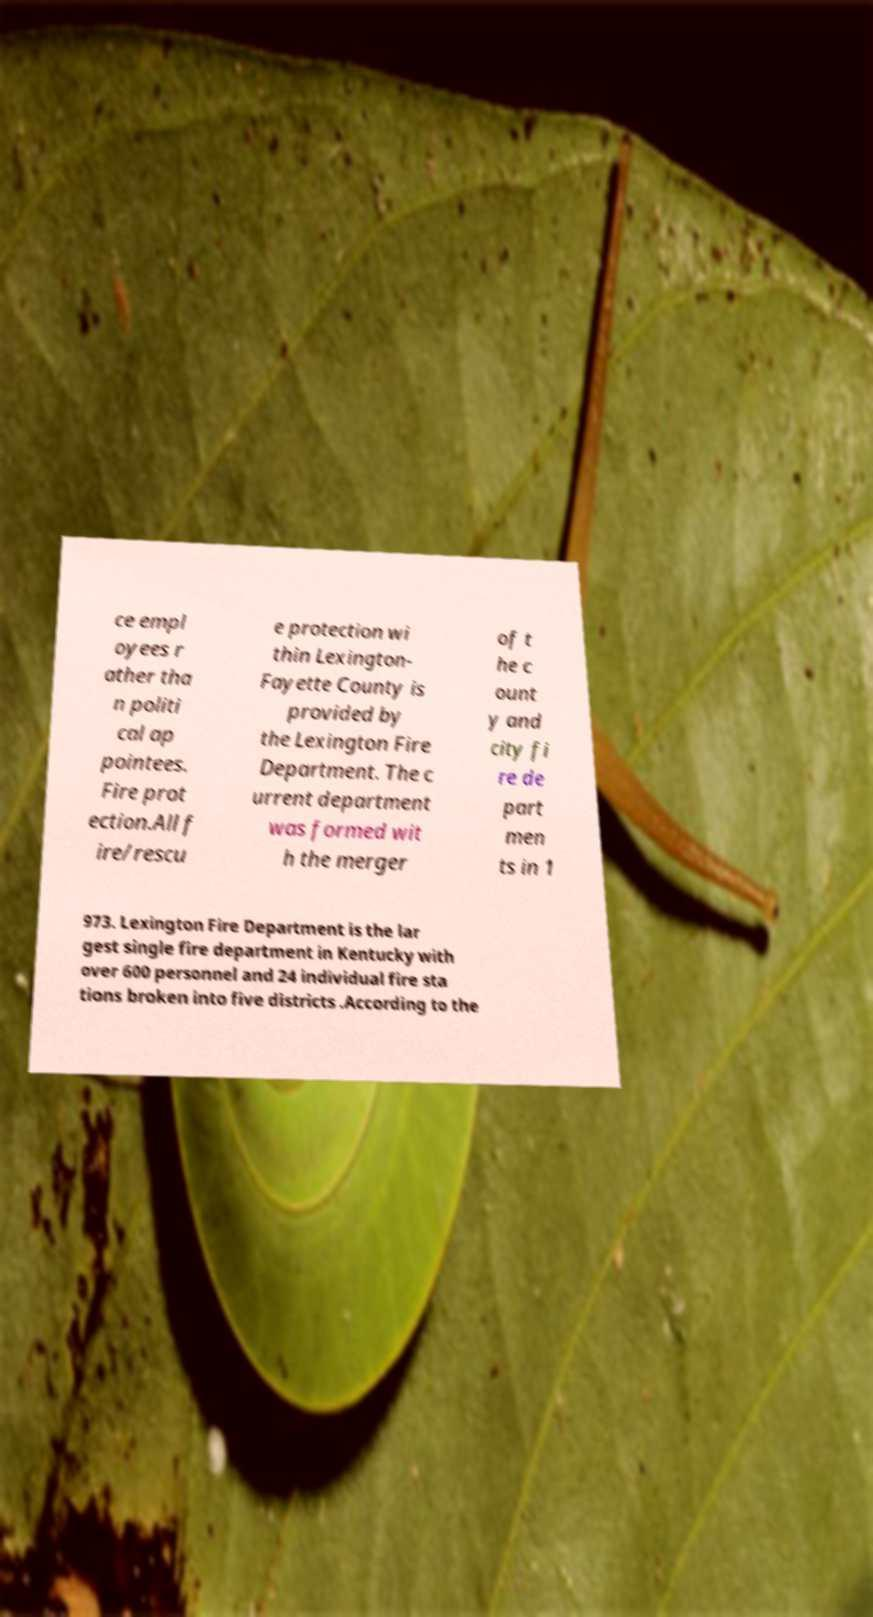Please read and relay the text visible in this image. What does it say? ce empl oyees r ather tha n politi cal ap pointees. Fire prot ection.All f ire/rescu e protection wi thin Lexington- Fayette County is provided by the Lexington Fire Department. The c urrent department was formed wit h the merger of t he c ount y and city fi re de part men ts in 1 973. Lexington Fire Department is the lar gest single fire department in Kentucky with over 600 personnel and 24 individual fire sta tions broken into five districts .According to the 